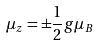Convert formula to latex. <formula><loc_0><loc_0><loc_500><loc_500>\mu _ { z } = \pm \frac { 1 } { 2 } g \mu _ { B }</formula> 